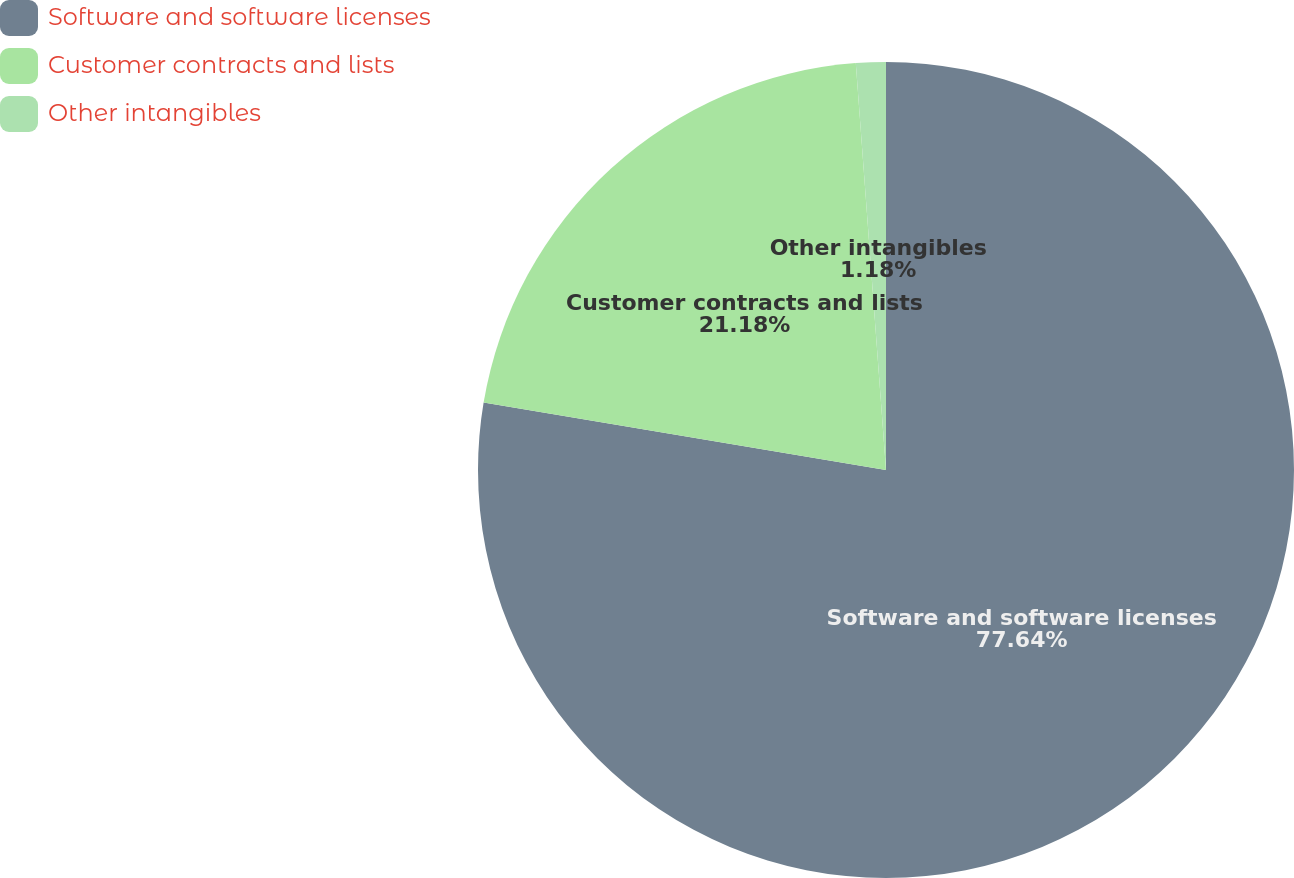Convert chart. <chart><loc_0><loc_0><loc_500><loc_500><pie_chart><fcel>Software and software licenses<fcel>Customer contracts and lists<fcel>Other intangibles<nl><fcel>77.65%<fcel>21.18%<fcel>1.18%<nl></chart> 